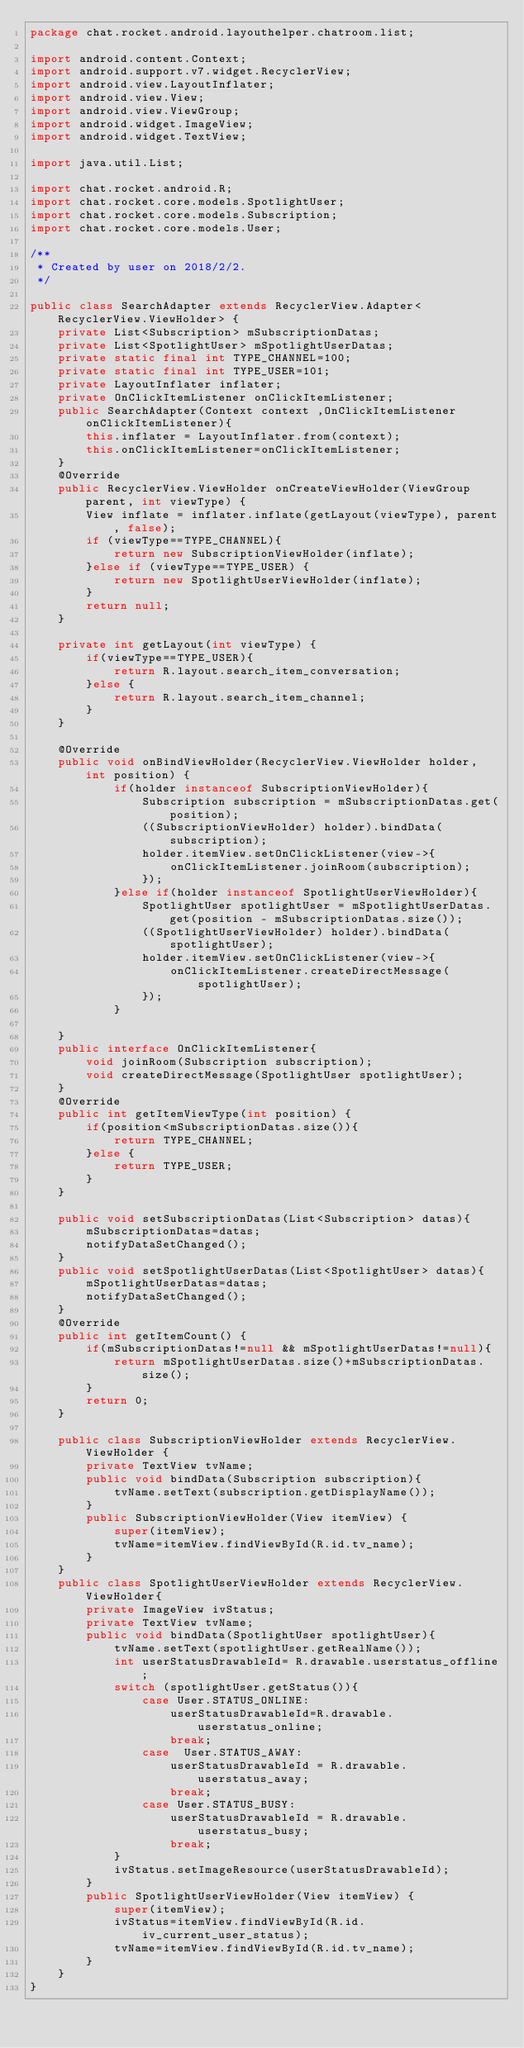Convert code to text. <code><loc_0><loc_0><loc_500><loc_500><_Java_>package chat.rocket.android.layouthelper.chatroom.list;

import android.content.Context;
import android.support.v7.widget.RecyclerView;
import android.view.LayoutInflater;
import android.view.View;
import android.view.ViewGroup;
import android.widget.ImageView;
import android.widget.TextView;

import java.util.List;

import chat.rocket.android.R;
import chat.rocket.core.models.SpotlightUser;
import chat.rocket.core.models.Subscription;
import chat.rocket.core.models.User;

/**
 * Created by user on 2018/2/2.
 */

public class SearchAdapter extends RecyclerView.Adapter<RecyclerView.ViewHolder> {
    private List<Subscription> mSubscriptionDatas;
    private List<SpotlightUser> mSpotlightUserDatas;
    private static final int TYPE_CHANNEL=100;
    private static final int TYPE_USER=101;
    private LayoutInflater inflater;
    private OnClickItemListener onClickItemListener;
    public SearchAdapter(Context context ,OnClickItemListener onClickItemListener){
        this.inflater = LayoutInflater.from(context);
        this.onClickItemListener=onClickItemListener;
    }
    @Override
    public RecyclerView.ViewHolder onCreateViewHolder(ViewGroup parent, int viewType) {
        View inflate = inflater.inflate(getLayout(viewType), parent, false);
        if (viewType==TYPE_CHANNEL){
            return new SubscriptionViewHolder(inflate);
        }else if (viewType==TYPE_USER) {
            return new SpotlightUserViewHolder(inflate);
        }
        return null;
    }

    private int getLayout(int viewType) {
        if(viewType==TYPE_USER){
            return R.layout.search_item_conversation;
        }else {
            return R.layout.search_item_channel;
        }
    }

    @Override
    public void onBindViewHolder(RecyclerView.ViewHolder holder, int position) {
            if(holder instanceof SubscriptionViewHolder){
                Subscription subscription = mSubscriptionDatas.get(position);
                ((SubscriptionViewHolder) holder).bindData(subscription);
                holder.itemView.setOnClickListener(view->{
                    onClickItemListener.joinRoom(subscription);
                });
            }else if(holder instanceof SpotlightUserViewHolder){
                SpotlightUser spotlightUser = mSpotlightUserDatas.get(position - mSubscriptionDatas.size());
                ((SpotlightUserViewHolder) holder).bindData(spotlightUser);
                holder.itemView.setOnClickListener(view->{
                    onClickItemListener.createDirectMessage(spotlightUser);
                });
            }

    }
    public interface OnClickItemListener{
        void joinRoom(Subscription subscription);
        void createDirectMessage(SpotlightUser spotlightUser);
    }
    @Override
    public int getItemViewType(int position) {
        if(position<mSubscriptionDatas.size()){
            return TYPE_CHANNEL;
        }else {
            return TYPE_USER;
        }
    }

    public void setSubscriptionDatas(List<Subscription> datas){
        mSubscriptionDatas=datas;
        notifyDataSetChanged();
    }
    public void setSpotlightUserDatas(List<SpotlightUser> datas){
        mSpotlightUserDatas=datas;
        notifyDataSetChanged();
    }
    @Override
    public int getItemCount() {
        if(mSubscriptionDatas!=null && mSpotlightUserDatas!=null){
            return mSpotlightUserDatas.size()+mSubscriptionDatas.size();
        }
        return 0;
    }

    public class SubscriptionViewHolder extends RecyclerView.ViewHolder {
        private TextView tvName;
        public void bindData(Subscription subscription){
            tvName.setText(subscription.getDisplayName());
        }
        public SubscriptionViewHolder(View itemView) {
            super(itemView);
            tvName=itemView.findViewById(R.id.tv_name);
        }
    }
    public class SpotlightUserViewHolder extends RecyclerView.ViewHolder{
        private ImageView ivStatus;
        private TextView tvName;
        public void bindData(SpotlightUser spotlightUser){
            tvName.setText(spotlightUser.getRealName());
            int userStatusDrawableId= R.drawable.userstatus_offline;
            switch (spotlightUser.getStatus()){
                case User.STATUS_ONLINE:
                    userStatusDrawableId=R.drawable.userstatus_online;
                    break;
                case  User.STATUS_AWAY:
                    userStatusDrawableId = R.drawable.userstatus_away;
                    break;
                case User.STATUS_BUSY:
                    userStatusDrawableId = R.drawable.userstatus_busy;
                    break;
            }
            ivStatus.setImageResource(userStatusDrawableId);
        }
        public SpotlightUserViewHolder(View itemView) {
            super(itemView);
            ivStatus=itemView.findViewById(R.id.iv_current_user_status);
            tvName=itemView.findViewById(R.id.tv_name);
        }
    }
}
</code> 